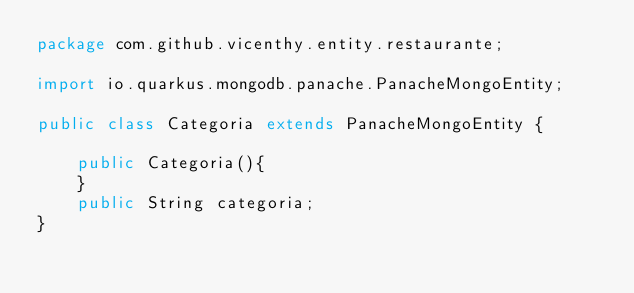Convert code to text. <code><loc_0><loc_0><loc_500><loc_500><_Java_>package com.github.vicenthy.entity.restaurante;

import io.quarkus.mongodb.panache.PanacheMongoEntity;

public class Categoria extends PanacheMongoEntity {

    public Categoria(){
    }
    public String categoria;
}
</code> 